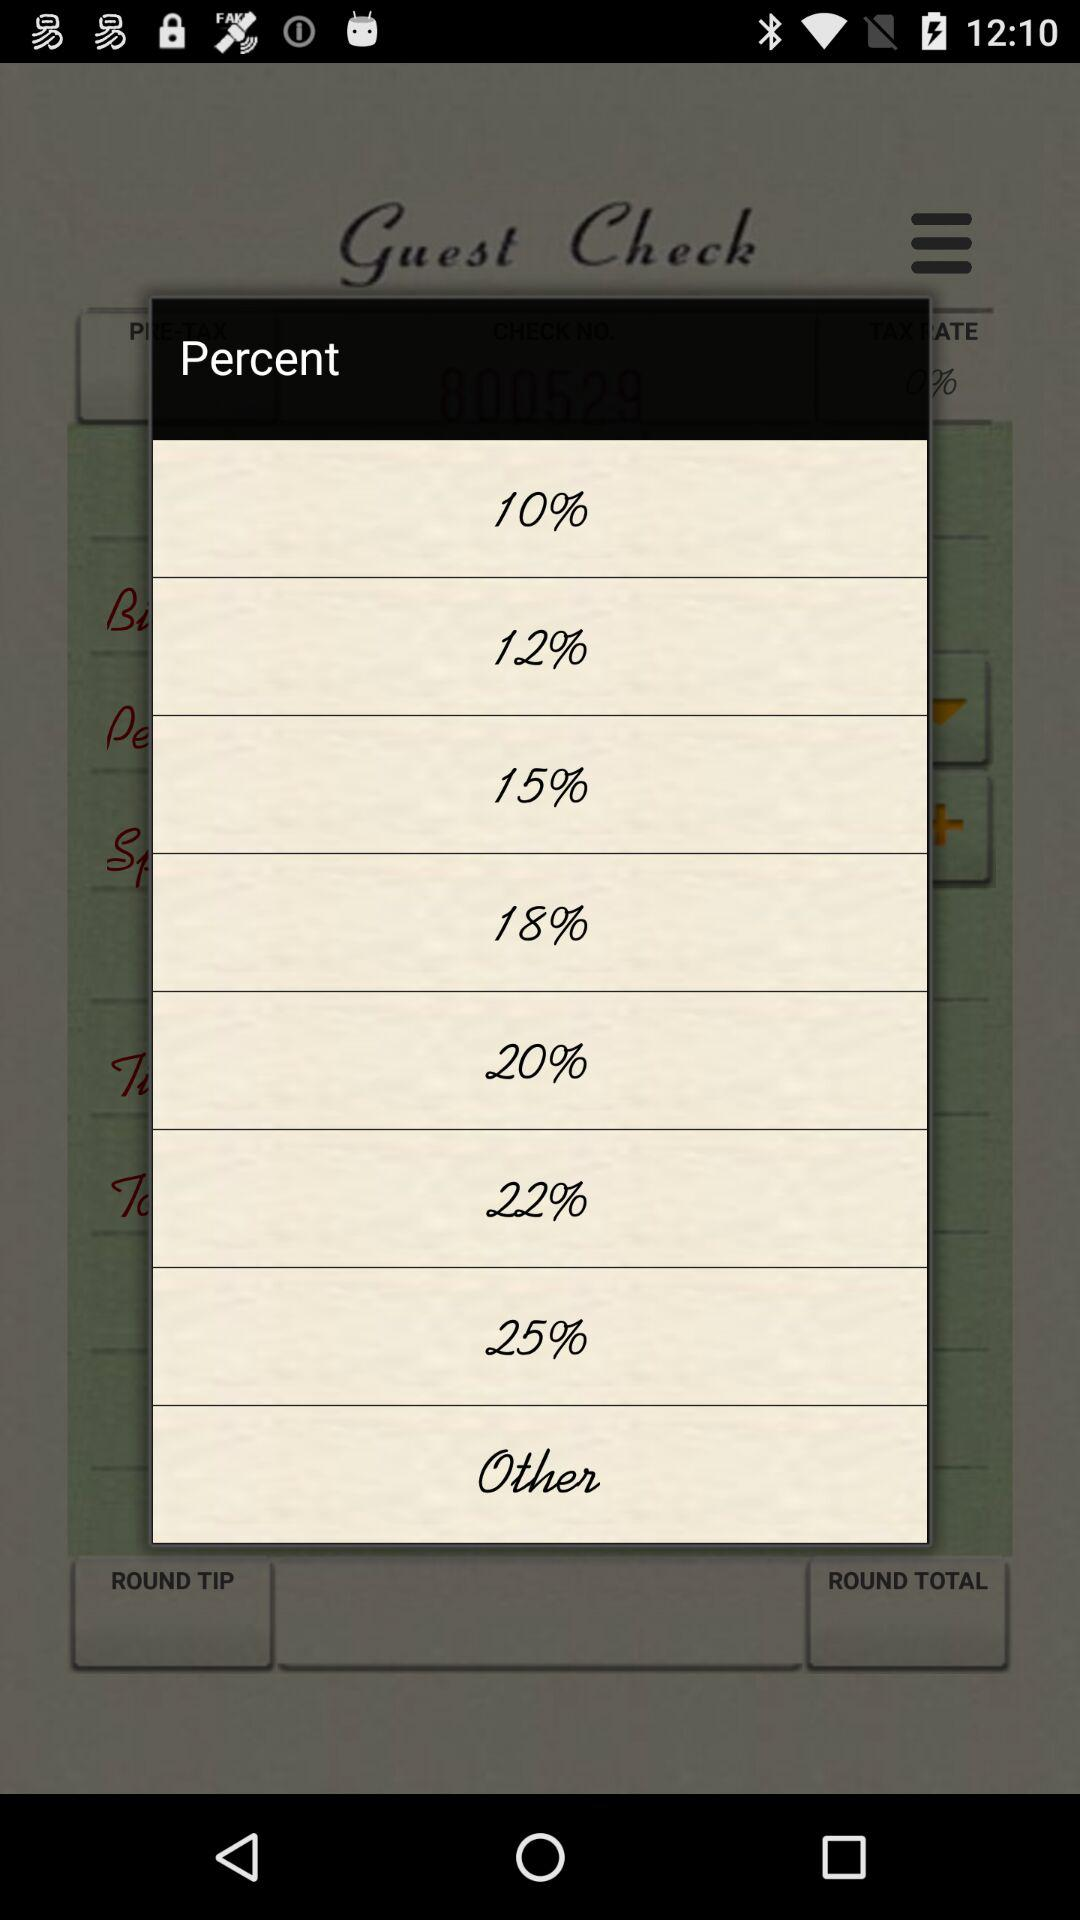What is the difference in percentage between the highest and lowest rates?
Answer the question using a single word or phrase. 15% 